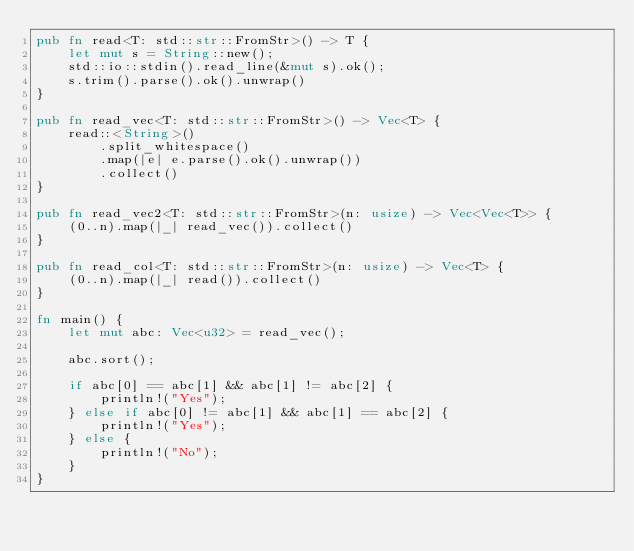Convert code to text. <code><loc_0><loc_0><loc_500><loc_500><_Rust_>pub fn read<T: std::str::FromStr>() -> T {
    let mut s = String::new();
    std::io::stdin().read_line(&mut s).ok();
    s.trim().parse().ok().unwrap()
}

pub fn read_vec<T: std::str::FromStr>() -> Vec<T> {
    read::<String>()
        .split_whitespace()
        .map(|e| e.parse().ok().unwrap())
        .collect()
}

pub fn read_vec2<T: std::str::FromStr>(n: usize) -> Vec<Vec<T>> {
    (0..n).map(|_| read_vec()).collect()
}

pub fn read_col<T: std::str::FromStr>(n: usize) -> Vec<T> {
    (0..n).map(|_| read()).collect()
}

fn main() {
    let mut abc: Vec<u32> = read_vec();

    abc.sort();

    if abc[0] == abc[1] && abc[1] != abc[2] {
        println!("Yes");
    } else if abc[0] != abc[1] && abc[1] == abc[2] {
        println!("Yes");
    } else {
        println!("No");
    }
}
</code> 